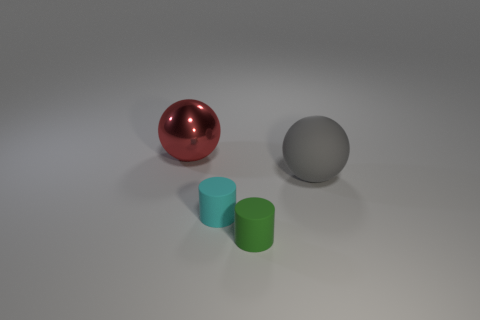What number of things are big spheres behind the big gray matte thing or large spheres left of the cyan cylinder? Behind the large gray matte sphere, there is one large red glossy sphere. To the left of the cyan cylinder, there is no large sphere present. Therefore, the count of big spheres either behind the gray sphere or left of the cyan cylinder is one. 